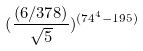Convert formula to latex. <formula><loc_0><loc_0><loc_500><loc_500>( \frac { ( 6 / 3 7 8 ) } { \sqrt { 5 } } ) ^ { ( 7 4 ^ { 4 } - 1 9 5 ) }</formula> 